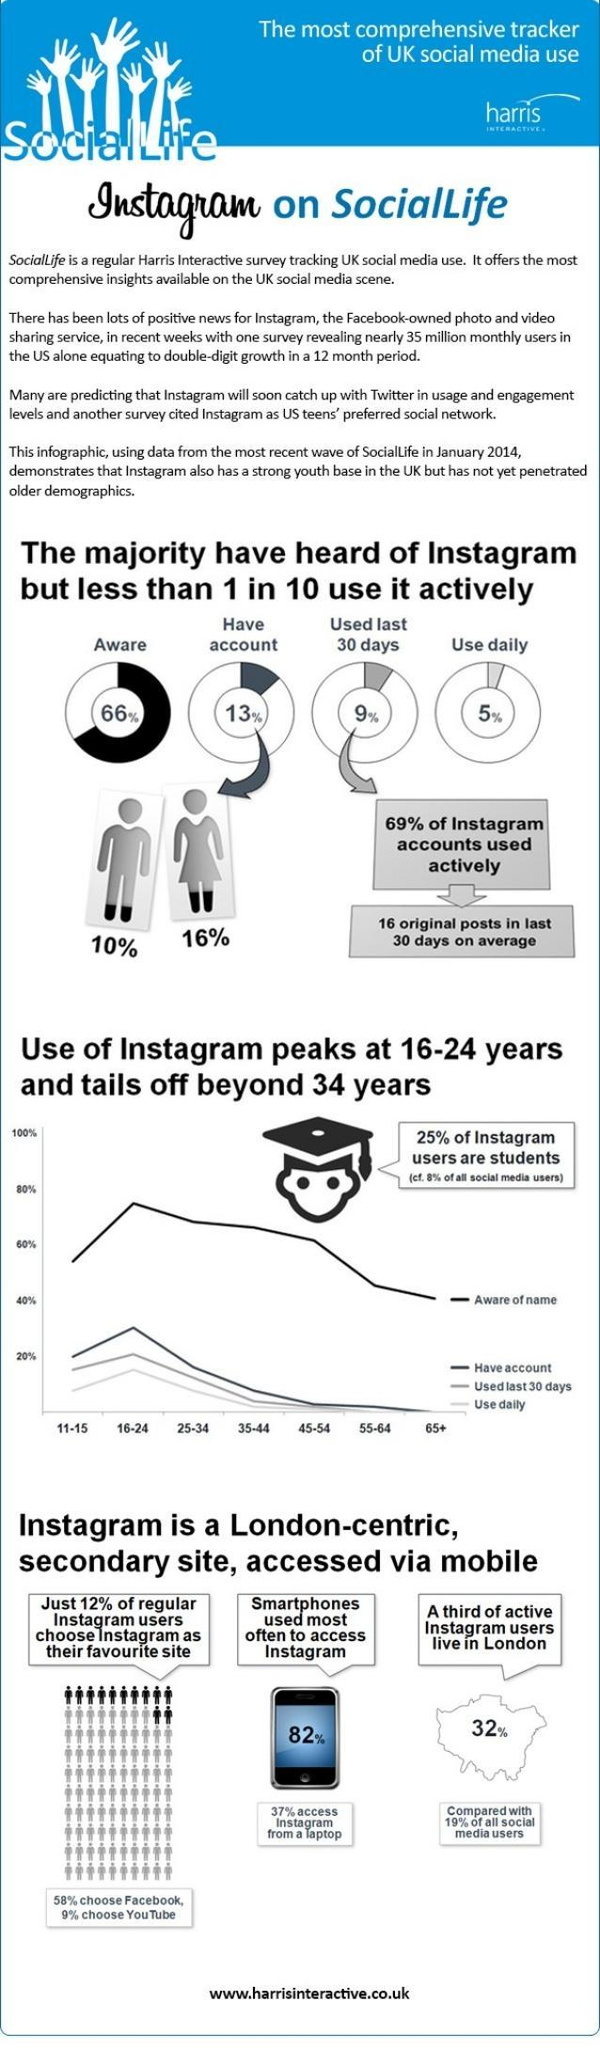What percentage of UK people are unaware of instagram as of January 2014?
Answer the question with a short phrase. 34% What percent of UK people used smartphones to access instagram as of January 2014? 82% What percentage of instagram accounts in UK are used daily as of January 2014? 5% What percent of instagram users lives in London as of January 2014? 32% What percent of account holders of instagram in UK are males as of January 2014? 10% What percent of account holders of instagram in UK are females as of January 2014? 16% 